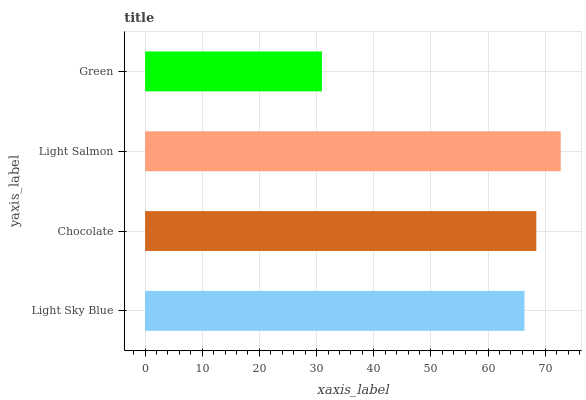Is Green the minimum?
Answer yes or no. Yes. Is Light Salmon the maximum?
Answer yes or no. Yes. Is Chocolate the minimum?
Answer yes or no. No. Is Chocolate the maximum?
Answer yes or no. No. Is Chocolate greater than Light Sky Blue?
Answer yes or no. Yes. Is Light Sky Blue less than Chocolate?
Answer yes or no. Yes. Is Light Sky Blue greater than Chocolate?
Answer yes or no. No. Is Chocolate less than Light Sky Blue?
Answer yes or no. No. Is Chocolate the high median?
Answer yes or no. Yes. Is Light Sky Blue the low median?
Answer yes or no. Yes. Is Light Salmon the high median?
Answer yes or no. No. Is Light Salmon the low median?
Answer yes or no. No. 